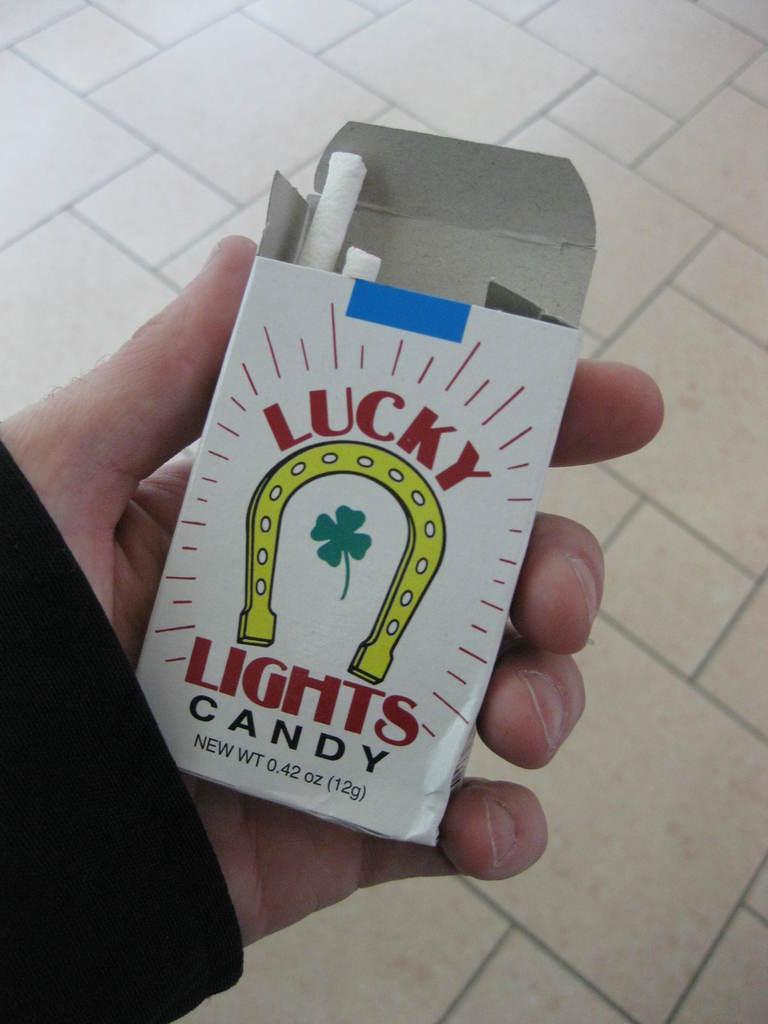Can you describe this image briefly? In this image, I can see a person's hand holding a cigarette pack. In the background, I can see the floor. 